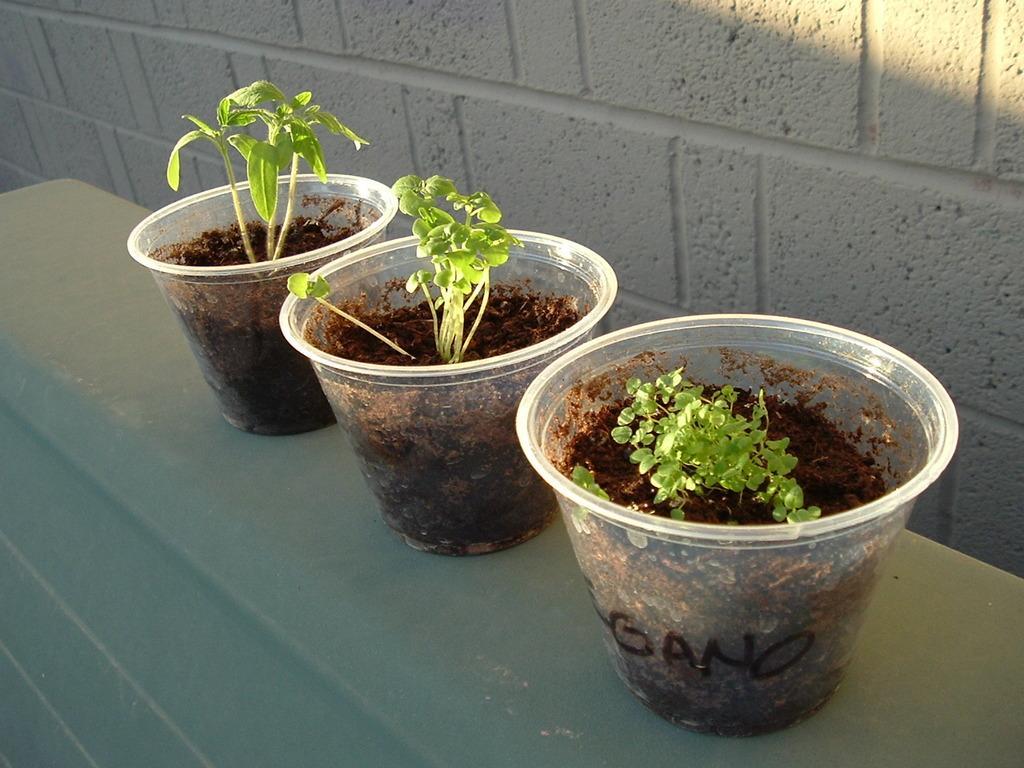Describe this image in one or two sentences. In this picture we can see three house plants on a table and in the background we can see the wall. 